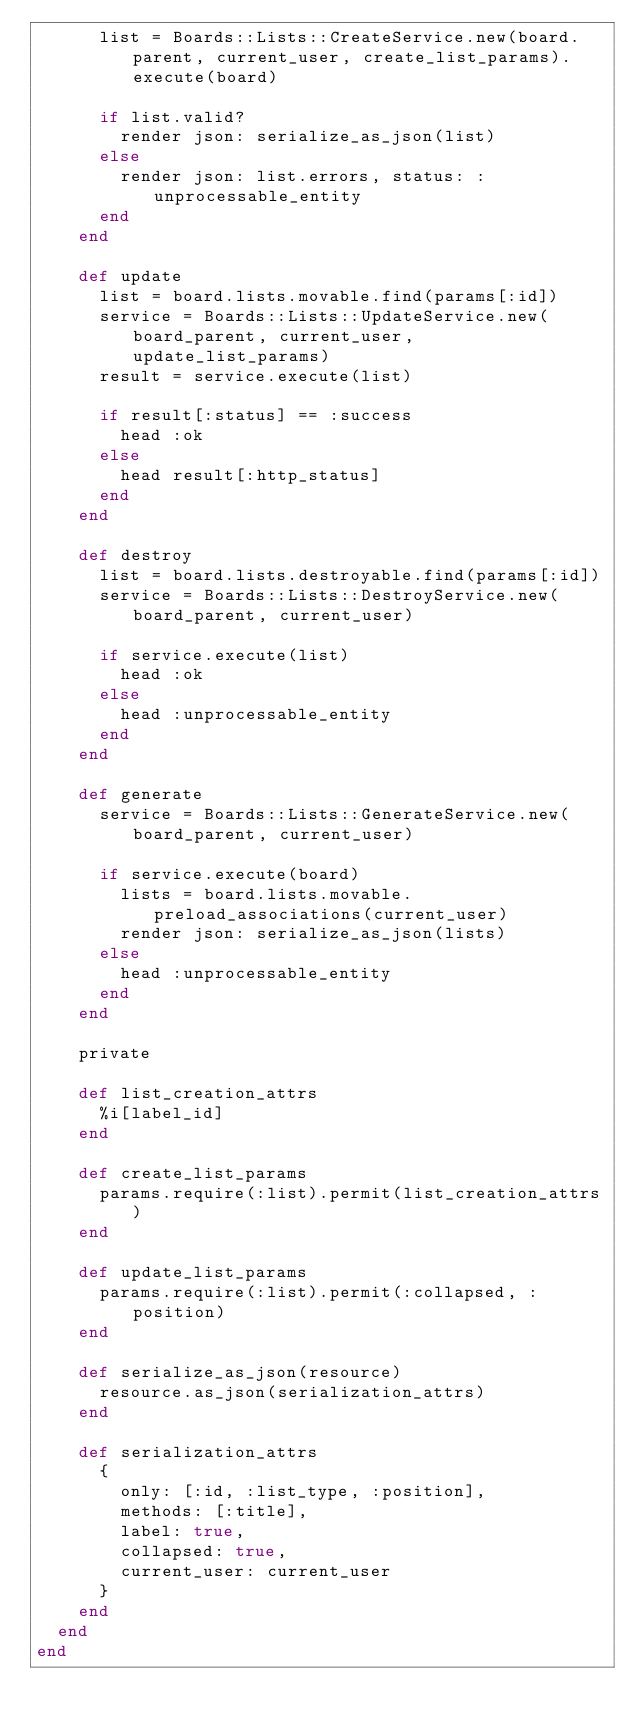<code> <loc_0><loc_0><loc_500><loc_500><_Ruby_>      list = Boards::Lists::CreateService.new(board.parent, current_user, create_list_params).execute(board)

      if list.valid?
        render json: serialize_as_json(list)
      else
        render json: list.errors, status: :unprocessable_entity
      end
    end

    def update
      list = board.lists.movable.find(params[:id])
      service = Boards::Lists::UpdateService.new(board_parent, current_user, update_list_params)
      result = service.execute(list)

      if result[:status] == :success
        head :ok
      else
        head result[:http_status]
      end
    end

    def destroy
      list = board.lists.destroyable.find(params[:id])
      service = Boards::Lists::DestroyService.new(board_parent, current_user)

      if service.execute(list)
        head :ok
      else
        head :unprocessable_entity
      end
    end

    def generate
      service = Boards::Lists::GenerateService.new(board_parent, current_user)

      if service.execute(board)
        lists = board.lists.movable.preload_associations(current_user)
        render json: serialize_as_json(lists)
      else
        head :unprocessable_entity
      end
    end

    private

    def list_creation_attrs
      %i[label_id]
    end

    def create_list_params
      params.require(:list).permit(list_creation_attrs)
    end

    def update_list_params
      params.require(:list).permit(:collapsed, :position)
    end

    def serialize_as_json(resource)
      resource.as_json(serialization_attrs)
    end

    def serialization_attrs
      {
        only: [:id, :list_type, :position],
        methods: [:title],
        label: true,
        collapsed: true,
        current_user: current_user
      }
    end
  end
end
</code> 